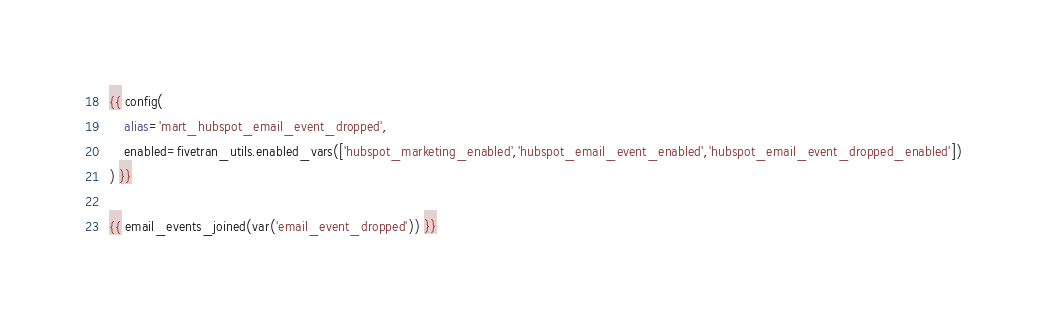Convert code to text. <code><loc_0><loc_0><loc_500><loc_500><_SQL_>{{ config(
    alias='mart_hubspot_email_event_dropped',
    enabled=fivetran_utils.enabled_vars(['hubspot_marketing_enabled','hubspot_email_event_enabled','hubspot_email_event_dropped_enabled'])
) }}

{{ email_events_joined(var('email_event_dropped')) }}
</code> 